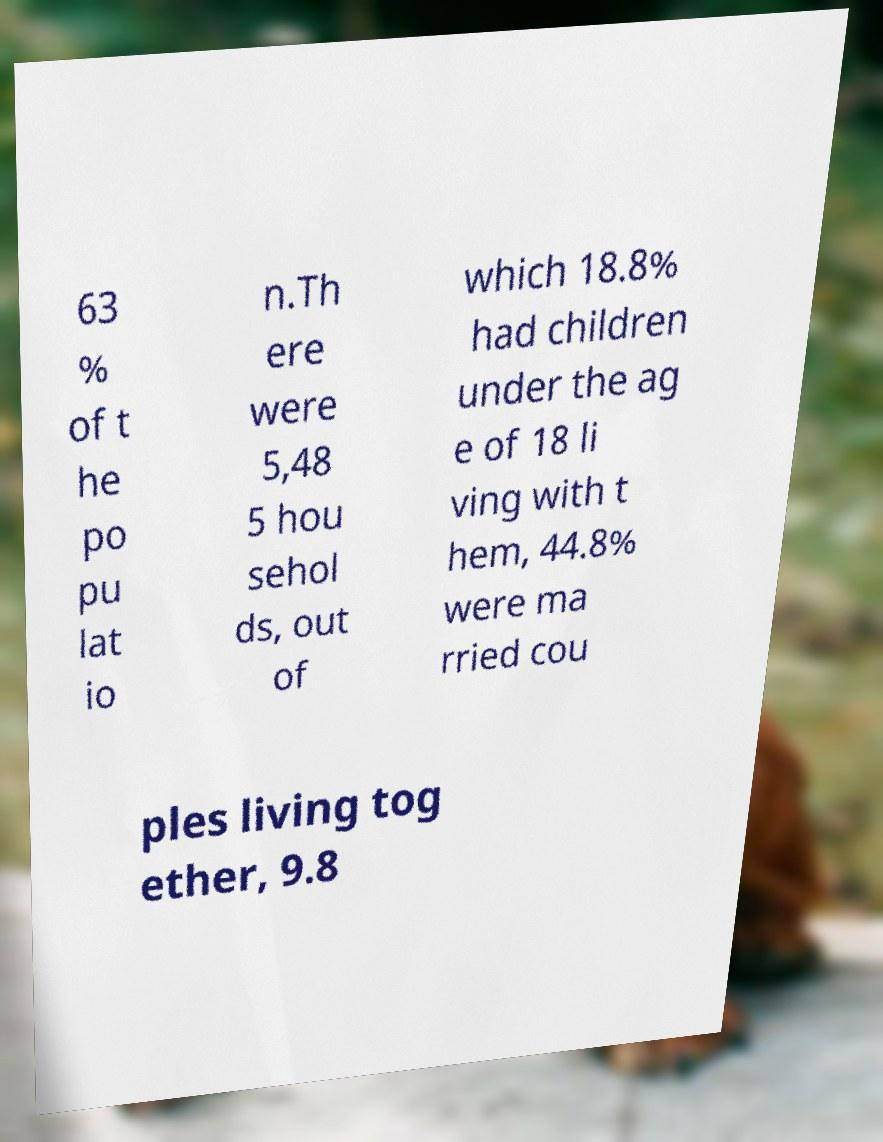Please read and relay the text visible in this image. What does it say? 63 % of t he po pu lat io n.Th ere were 5,48 5 hou sehol ds, out of which 18.8% had children under the ag e of 18 li ving with t hem, 44.8% were ma rried cou ples living tog ether, 9.8 